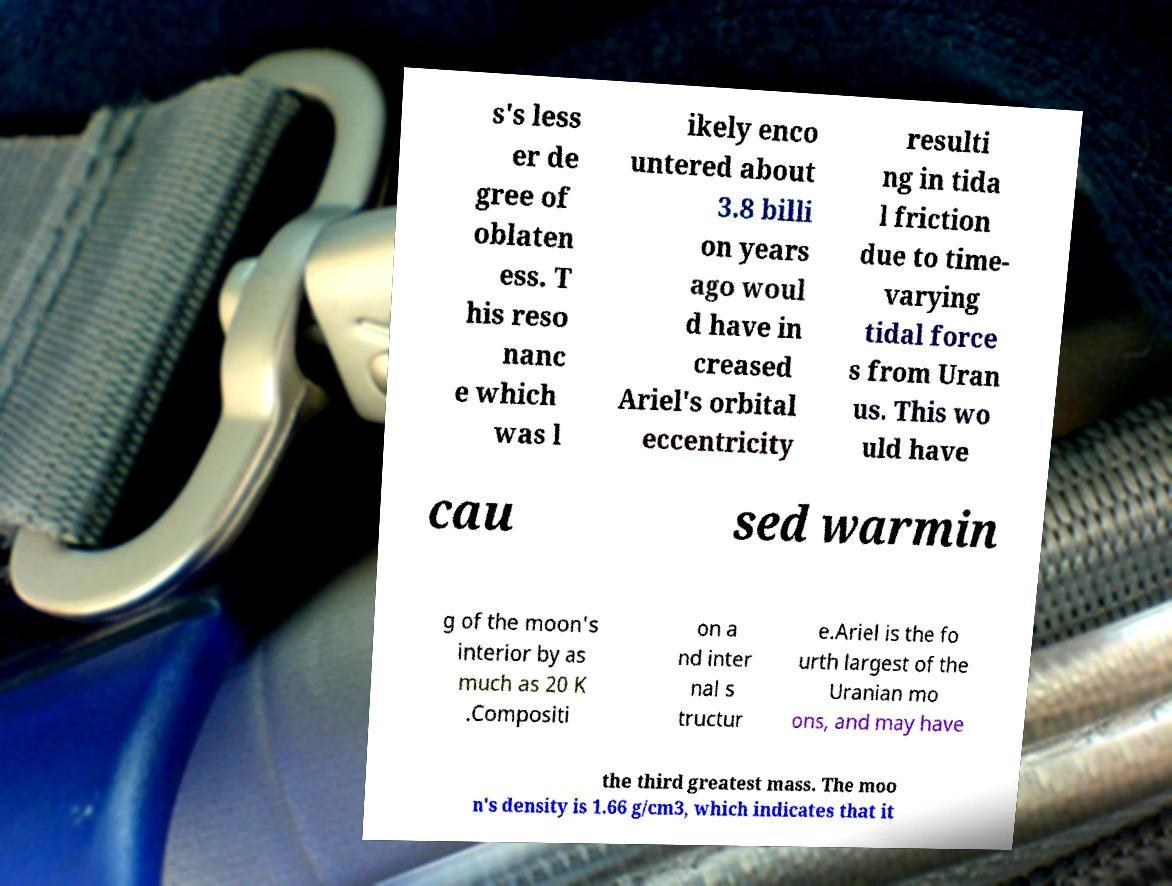Could you extract and type out the text from this image? s's less er de gree of oblaten ess. T his reso nanc e which was l ikely enco untered about 3.8 billi on years ago woul d have in creased Ariel's orbital eccentricity resulti ng in tida l friction due to time- varying tidal force s from Uran us. This wo uld have cau sed warmin g of the moon's interior by as much as 20 K .Compositi on a nd inter nal s tructur e.Ariel is the fo urth largest of the Uranian mo ons, and may have the third greatest mass. The moo n's density is 1.66 g/cm3, which indicates that it 